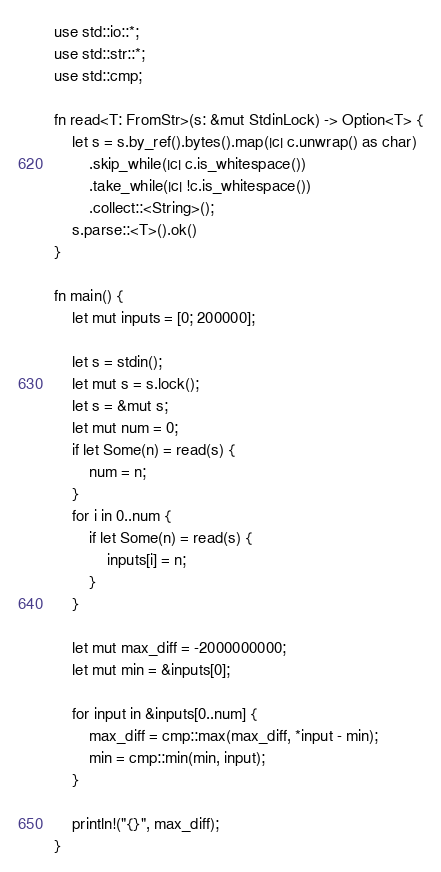Convert code to text. <code><loc_0><loc_0><loc_500><loc_500><_Rust_>use std::io::*;
use std::str::*;
use std::cmp;

fn read<T: FromStr>(s: &mut StdinLock) -> Option<T> {
    let s = s.by_ref().bytes().map(|c| c.unwrap() as char)
        .skip_while(|c| c.is_whitespace())
        .take_while(|c| !c.is_whitespace())
        .collect::<String>();
    s.parse::<T>().ok()
}

fn main() {
    let mut inputs = [0; 200000];
    
    let s = stdin();
    let mut s = s.lock();
    let s = &mut s;
    let mut num = 0;
    if let Some(n) = read(s) {
        num = n;
    }
    for i in 0..num {
        if let Some(n) = read(s) {
            inputs[i] = n;
        }
    }
    
    let mut max_diff = -2000000000;
    let mut min = &inputs[0];

    for input in &inputs[0..num] {
        max_diff = cmp::max(max_diff, *input - min);
        min = cmp::min(min, input);
    }

    println!("{}", max_diff);
}
</code> 